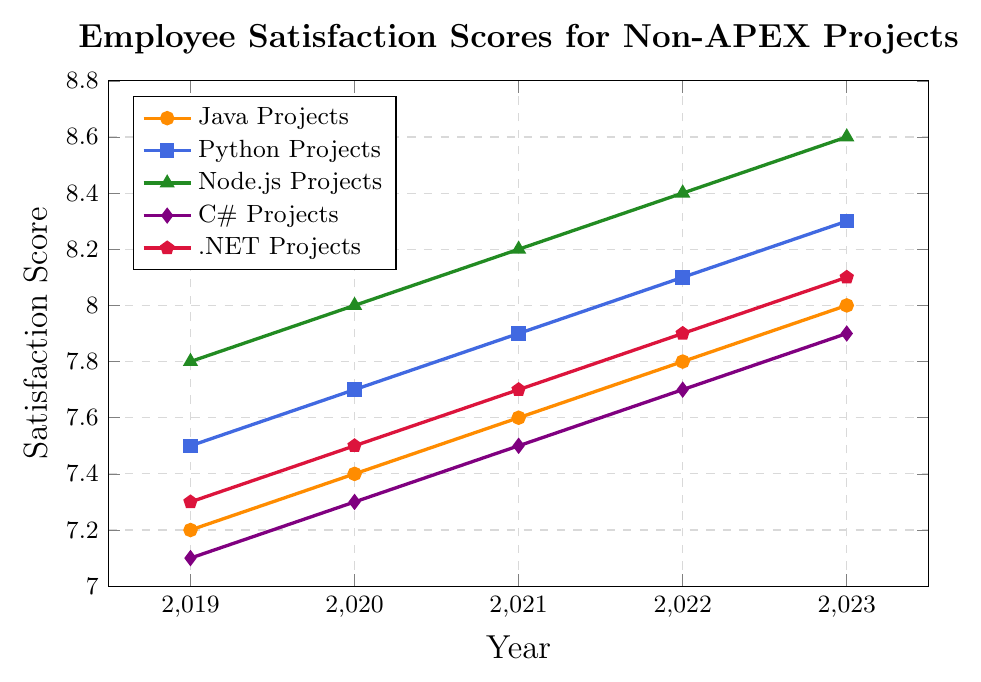What's the satisfaction score for Python projects in 2022? Locate the line corresponding to Python projects (in blue) and find the satisfaction score for the year 2022.
Answer: 8.1 Which project type showed the highest satisfaction score in 2023? Identify the highest point among all lines in 2023. Node.js projects have the highest score.
Answer: Node.js Projects How did the satisfaction score for C# projects change from 2019 to 2023? Trace the line corresponding to C# projects (in purple) from 2019 to 2023. Subtract the score in 2019 from the score in 2023. 7.9 - 7.1 = 0.8
Answer: Increased by 0.8 Which project type had the lowest satisfaction score in 2019? Compare the lowest points among all the lines in 2019; the C# projects line is the lowest.
Answer: C# Projects What is the average satisfaction score of .NET projects from 2019 to 2023? Sum the satisfaction scores for .NET projects from 2019 to 2023 and divide by the number of years (5). (7.3 + 7.5 + 7.7 + 7.9 + 8.1) / 5 = 7.7
Answer: 7.7 Between which years did Java projects see the biggest increase in satisfaction score? Track the Java projects' line and calculate yearly differences. The biggest increase occurs between 2022 and 2023, where the score increased by 0.2.
Answer: Between 2022 and 2023 Compare the satisfaction scores of Node.js projects and C# projects in 2021. Find the satisfaction scores for Node.js projects (in green) and C# projects (in purple) in 2021. Node.js: 8.2, C#: 7.5
Answer: Node.js: 8.2, C#: 7.5 What is the trend of the satisfaction scores for Python projects over the 5 years? Observe the line for Python projects (in blue) from 2019 to 2023. The trend is consistently upward.
Answer: Increasing Which project type's satisfaction scores exceeded 8.0 starting from 2021 onward? Check the lines above 8.0 from 2021 onwards. Node.js scores start exceeding 8.0 from 2020. Python projects start from 2022 and .NET from 2023.
Answer: Node.js (2020), Python (2022), .NET (2023) Estimate the difference in satisfaction scores between Java and .NET projects in 2023. Find the satisfaction scores for Java and .NET projects in 2023. Calculate the difference. 8.0 - 8.1 = -0.1
Answer: -0.1 